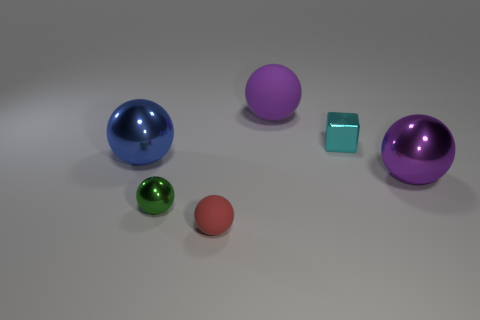Subtract all green spheres. How many spheres are left? 4 Subtract all red rubber spheres. How many spheres are left? 4 Subtract all brown spheres. Subtract all brown cubes. How many spheres are left? 5 Add 3 big green shiny cubes. How many objects exist? 9 Subtract all balls. How many objects are left? 1 Subtract all small shiny spheres. Subtract all tiny gray blocks. How many objects are left? 5 Add 6 small blocks. How many small blocks are left? 7 Add 4 big balls. How many big balls exist? 7 Subtract 0 red blocks. How many objects are left? 6 